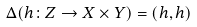Convert formula to latex. <formula><loc_0><loc_0><loc_500><loc_500>\Delta ( h \colon Z \to X \times Y ) = ( h , h )</formula> 